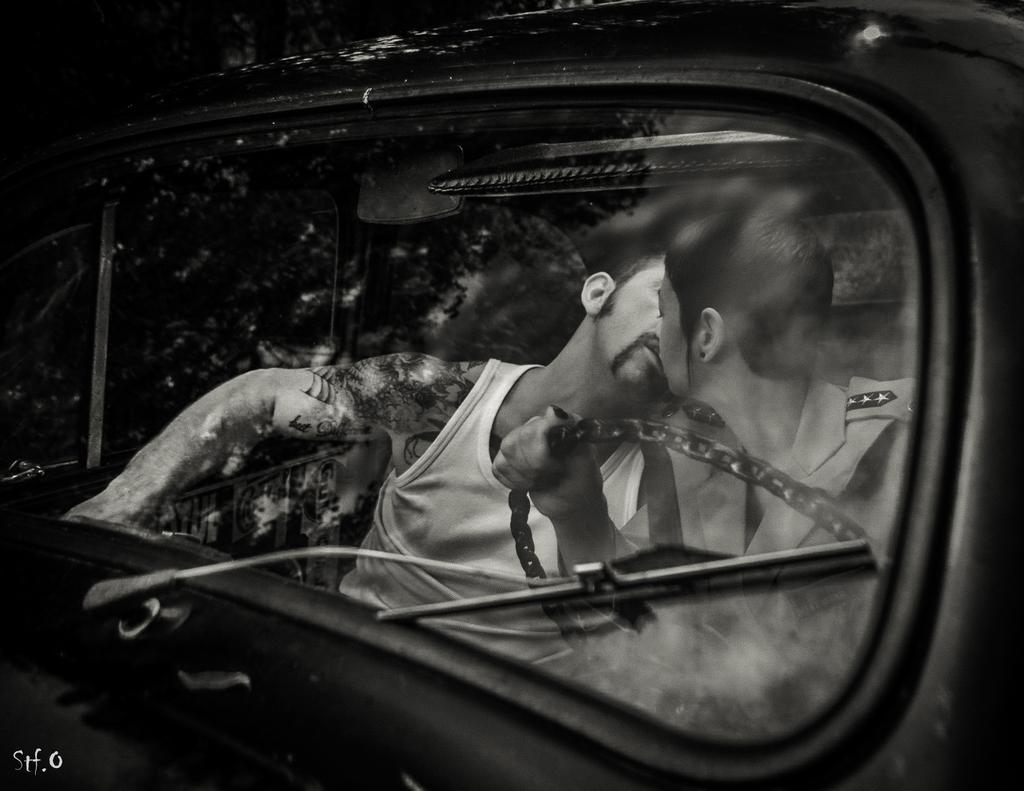How would you summarize this image in a sentence or two? In this image i can see a car and there are the two persons sitting on the car and one person holding a steering of the car 